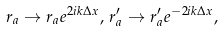Convert formula to latex. <formula><loc_0><loc_0><loc_500><loc_500>r _ { a } \rightarrow r _ { a } e ^ { 2 i k \Delta x } , \, r _ { a } ^ { \prime } \rightarrow r _ { a } ^ { \prime } e ^ { - 2 i k \Delta x } ,</formula> 